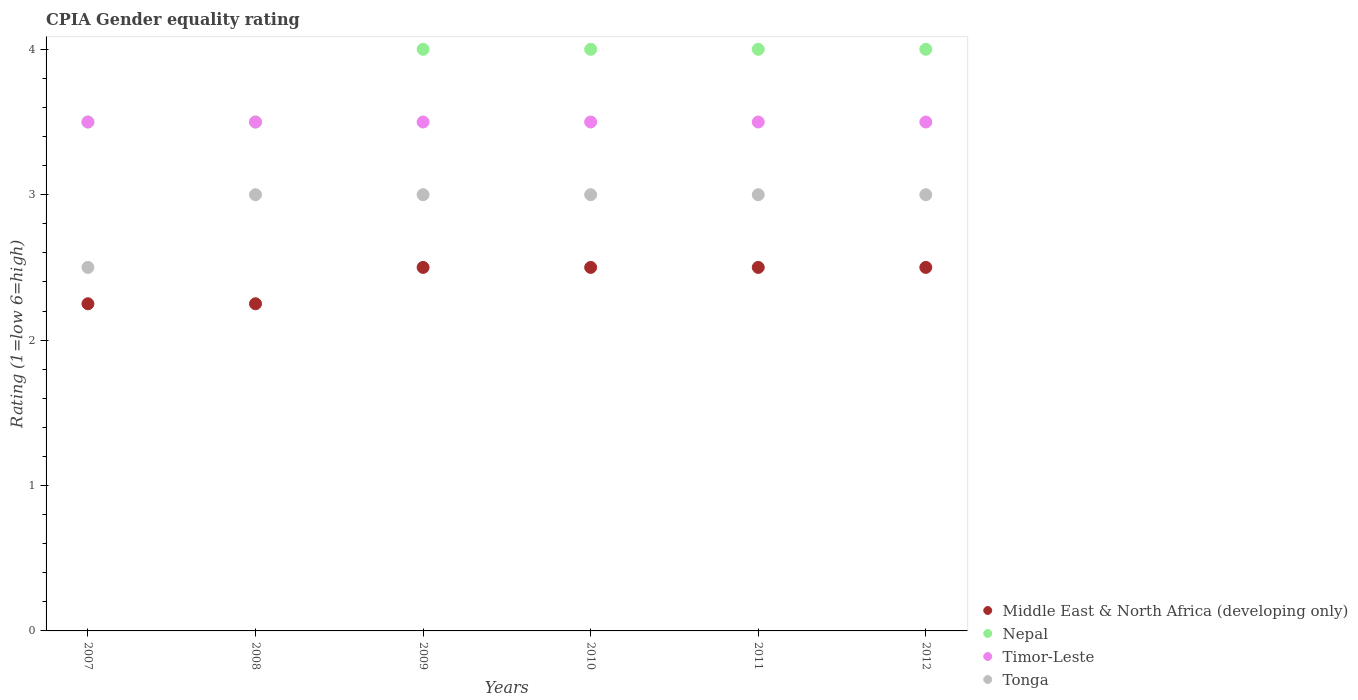How many different coloured dotlines are there?
Provide a succinct answer. 4. Across all years, what is the maximum CPIA rating in Tonga?
Give a very brief answer. 3. In which year was the CPIA rating in Timor-Leste maximum?
Ensure brevity in your answer.  2007. In which year was the CPIA rating in Tonga minimum?
Offer a terse response. 2007. What is the difference between the CPIA rating in Timor-Leste in 2009 and that in 2011?
Your response must be concise. 0. What is the difference between the CPIA rating in Tonga in 2012 and the CPIA rating in Timor-Leste in 2008?
Provide a succinct answer. -0.5. In the year 2011, what is the difference between the CPIA rating in Nepal and CPIA rating in Timor-Leste?
Provide a succinct answer. 0.5. In how many years, is the CPIA rating in Middle East & North Africa (developing only) greater than 1.6?
Offer a terse response. 6. Is the CPIA rating in Nepal in 2009 less than that in 2010?
Provide a succinct answer. No. Is the difference between the CPIA rating in Nepal in 2007 and 2008 greater than the difference between the CPIA rating in Timor-Leste in 2007 and 2008?
Ensure brevity in your answer.  No. What is the difference between the highest and the second highest CPIA rating in Middle East & North Africa (developing only)?
Ensure brevity in your answer.  0. In how many years, is the CPIA rating in Middle East & North Africa (developing only) greater than the average CPIA rating in Middle East & North Africa (developing only) taken over all years?
Your response must be concise. 4. Does the CPIA rating in Middle East & North Africa (developing only) monotonically increase over the years?
Keep it short and to the point. No. Is the CPIA rating in Tonga strictly less than the CPIA rating in Middle East & North Africa (developing only) over the years?
Keep it short and to the point. No. Does the graph contain any zero values?
Provide a short and direct response. No. Does the graph contain grids?
Offer a very short reply. No. Where does the legend appear in the graph?
Offer a very short reply. Bottom right. What is the title of the graph?
Your answer should be compact. CPIA Gender equality rating. What is the label or title of the X-axis?
Keep it short and to the point. Years. What is the label or title of the Y-axis?
Give a very brief answer. Rating (1=low 6=high). What is the Rating (1=low 6=high) of Middle East & North Africa (developing only) in 2007?
Your response must be concise. 2.25. What is the Rating (1=low 6=high) of Nepal in 2007?
Ensure brevity in your answer.  3.5. What is the Rating (1=low 6=high) of Tonga in 2007?
Ensure brevity in your answer.  2.5. What is the Rating (1=low 6=high) of Middle East & North Africa (developing only) in 2008?
Provide a succinct answer. 2.25. What is the Rating (1=low 6=high) of Tonga in 2008?
Ensure brevity in your answer.  3. What is the Rating (1=low 6=high) of Timor-Leste in 2009?
Provide a succinct answer. 3.5. What is the Rating (1=low 6=high) of Tonga in 2009?
Provide a succinct answer. 3. What is the Rating (1=low 6=high) of Nepal in 2010?
Give a very brief answer. 4. What is the Rating (1=low 6=high) of Timor-Leste in 2010?
Your response must be concise. 3.5. What is the Rating (1=low 6=high) of Tonga in 2010?
Make the answer very short. 3. What is the Rating (1=low 6=high) of Middle East & North Africa (developing only) in 2011?
Give a very brief answer. 2.5. What is the Rating (1=low 6=high) of Nepal in 2011?
Give a very brief answer. 4. What is the Rating (1=low 6=high) in Middle East & North Africa (developing only) in 2012?
Your answer should be very brief. 2.5. What is the Rating (1=low 6=high) of Timor-Leste in 2012?
Keep it short and to the point. 3.5. What is the Rating (1=low 6=high) in Tonga in 2012?
Give a very brief answer. 3. Across all years, what is the maximum Rating (1=low 6=high) of Tonga?
Provide a succinct answer. 3. Across all years, what is the minimum Rating (1=low 6=high) in Middle East & North Africa (developing only)?
Your answer should be very brief. 2.25. Across all years, what is the minimum Rating (1=low 6=high) of Nepal?
Your response must be concise. 3.5. What is the difference between the Rating (1=low 6=high) in Timor-Leste in 2007 and that in 2008?
Your answer should be very brief. 0. What is the difference between the Rating (1=low 6=high) in Nepal in 2007 and that in 2009?
Provide a short and direct response. -0.5. What is the difference between the Rating (1=low 6=high) of Nepal in 2007 and that in 2011?
Give a very brief answer. -0.5. What is the difference between the Rating (1=low 6=high) in Timor-Leste in 2007 and that in 2011?
Give a very brief answer. 0. What is the difference between the Rating (1=low 6=high) in Timor-Leste in 2007 and that in 2012?
Offer a very short reply. 0. What is the difference between the Rating (1=low 6=high) in Tonga in 2007 and that in 2012?
Ensure brevity in your answer.  -0.5. What is the difference between the Rating (1=low 6=high) in Nepal in 2008 and that in 2009?
Your answer should be compact. -0.5. What is the difference between the Rating (1=low 6=high) in Tonga in 2008 and that in 2009?
Provide a short and direct response. 0. What is the difference between the Rating (1=low 6=high) in Middle East & North Africa (developing only) in 2008 and that in 2010?
Your response must be concise. -0.25. What is the difference between the Rating (1=low 6=high) in Nepal in 2008 and that in 2010?
Make the answer very short. -0.5. What is the difference between the Rating (1=low 6=high) of Timor-Leste in 2008 and that in 2010?
Provide a short and direct response. 0. What is the difference between the Rating (1=low 6=high) in Nepal in 2008 and that in 2011?
Offer a very short reply. -0.5. What is the difference between the Rating (1=low 6=high) in Tonga in 2008 and that in 2011?
Provide a short and direct response. 0. What is the difference between the Rating (1=low 6=high) of Middle East & North Africa (developing only) in 2008 and that in 2012?
Provide a succinct answer. -0.25. What is the difference between the Rating (1=low 6=high) in Timor-Leste in 2008 and that in 2012?
Offer a very short reply. 0. What is the difference between the Rating (1=low 6=high) of Tonga in 2008 and that in 2012?
Your answer should be compact. 0. What is the difference between the Rating (1=low 6=high) of Middle East & North Africa (developing only) in 2009 and that in 2011?
Your response must be concise. 0. What is the difference between the Rating (1=low 6=high) of Nepal in 2009 and that in 2011?
Offer a terse response. 0. What is the difference between the Rating (1=low 6=high) of Tonga in 2009 and that in 2011?
Give a very brief answer. 0. What is the difference between the Rating (1=low 6=high) in Nepal in 2009 and that in 2012?
Ensure brevity in your answer.  0. What is the difference between the Rating (1=low 6=high) in Tonga in 2009 and that in 2012?
Offer a very short reply. 0. What is the difference between the Rating (1=low 6=high) of Middle East & North Africa (developing only) in 2010 and that in 2011?
Offer a very short reply. 0. What is the difference between the Rating (1=low 6=high) of Nepal in 2010 and that in 2011?
Make the answer very short. 0. What is the difference between the Rating (1=low 6=high) in Tonga in 2010 and that in 2011?
Provide a short and direct response. 0. What is the difference between the Rating (1=low 6=high) of Nepal in 2010 and that in 2012?
Your response must be concise. 0. What is the difference between the Rating (1=low 6=high) in Timor-Leste in 2010 and that in 2012?
Provide a succinct answer. 0. What is the difference between the Rating (1=low 6=high) of Middle East & North Africa (developing only) in 2011 and that in 2012?
Offer a very short reply. 0. What is the difference between the Rating (1=low 6=high) of Nepal in 2011 and that in 2012?
Provide a short and direct response. 0. What is the difference between the Rating (1=low 6=high) of Middle East & North Africa (developing only) in 2007 and the Rating (1=low 6=high) of Nepal in 2008?
Give a very brief answer. -1.25. What is the difference between the Rating (1=low 6=high) of Middle East & North Africa (developing only) in 2007 and the Rating (1=low 6=high) of Timor-Leste in 2008?
Provide a short and direct response. -1.25. What is the difference between the Rating (1=low 6=high) in Middle East & North Africa (developing only) in 2007 and the Rating (1=low 6=high) in Tonga in 2008?
Offer a terse response. -0.75. What is the difference between the Rating (1=low 6=high) of Nepal in 2007 and the Rating (1=low 6=high) of Tonga in 2008?
Give a very brief answer. 0.5. What is the difference between the Rating (1=low 6=high) of Middle East & North Africa (developing only) in 2007 and the Rating (1=low 6=high) of Nepal in 2009?
Provide a succinct answer. -1.75. What is the difference between the Rating (1=low 6=high) of Middle East & North Africa (developing only) in 2007 and the Rating (1=low 6=high) of Timor-Leste in 2009?
Ensure brevity in your answer.  -1.25. What is the difference between the Rating (1=low 6=high) of Middle East & North Africa (developing only) in 2007 and the Rating (1=low 6=high) of Tonga in 2009?
Make the answer very short. -0.75. What is the difference between the Rating (1=low 6=high) in Nepal in 2007 and the Rating (1=low 6=high) in Timor-Leste in 2009?
Keep it short and to the point. 0. What is the difference between the Rating (1=low 6=high) in Middle East & North Africa (developing only) in 2007 and the Rating (1=low 6=high) in Nepal in 2010?
Your answer should be very brief. -1.75. What is the difference between the Rating (1=low 6=high) of Middle East & North Africa (developing only) in 2007 and the Rating (1=low 6=high) of Timor-Leste in 2010?
Your answer should be compact. -1.25. What is the difference between the Rating (1=low 6=high) of Middle East & North Africa (developing only) in 2007 and the Rating (1=low 6=high) of Tonga in 2010?
Make the answer very short. -0.75. What is the difference between the Rating (1=low 6=high) in Nepal in 2007 and the Rating (1=low 6=high) in Timor-Leste in 2010?
Provide a succinct answer. 0. What is the difference between the Rating (1=low 6=high) of Middle East & North Africa (developing only) in 2007 and the Rating (1=low 6=high) of Nepal in 2011?
Offer a very short reply. -1.75. What is the difference between the Rating (1=low 6=high) of Middle East & North Africa (developing only) in 2007 and the Rating (1=low 6=high) of Timor-Leste in 2011?
Your answer should be very brief. -1.25. What is the difference between the Rating (1=low 6=high) of Middle East & North Africa (developing only) in 2007 and the Rating (1=low 6=high) of Tonga in 2011?
Provide a succinct answer. -0.75. What is the difference between the Rating (1=low 6=high) of Nepal in 2007 and the Rating (1=low 6=high) of Timor-Leste in 2011?
Ensure brevity in your answer.  0. What is the difference between the Rating (1=low 6=high) in Nepal in 2007 and the Rating (1=low 6=high) in Tonga in 2011?
Offer a terse response. 0.5. What is the difference between the Rating (1=low 6=high) of Timor-Leste in 2007 and the Rating (1=low 6=high) of Tonga in 2011?
Provide a succinct answer. 0.5. What is the difference between the Rating (1=low 6=high) of Middle East & North Africa (developing only) in 2007 and the Rating (1=low 6=high) of Nepal in 2012?
Make the answer very short. -1.75. What is the difference between the Rating (1=low 6=high) of Middle East & North Africa (developing only) in 2007 and the Rating (1=low 6=high) of Timor-Leste in 2012?
Keep it short and to the point. -1.25. What is the difference between the Rating (1=low 6=high) in Middle East & North Africa (developing only) in 2007 and the Rating (1=low 6=high) in Tonga in 2012?
Ensure brevity in your answer.  -0.75. What is the difference between the Rating (1=low 6=high) in Nepal in 2007 and the Rating (1=low 6=high) in Tonga in 2012?
Your answer should be very brief. 0.5. What is the difference between the Rating (1=low 6=high) in Timor-Leste in 2007 and the Rating (1=low 6=high) in Tonga in 2012?
Offer a terse response. 0.5. What is the difference between the Rating (1=low 6=high) in Middle East & North Africa (developing only) in 2008 and the Rating (1=low 6=high) in Nepal in 2009?
Give a very brief answer. -1.75. What is the difference between the Rating (1=low 6=high) of Middle East & North Africa (developing only) in 2008 and the Rating (1=low 6=high) of Timor-Leste in 2009?
Keep it short and to the point. -1.25. What is the difference between the Rating (1=low 6=high) in Middle East & North Africa (developing only) in 2008 and the Rating (1=low 6=high) in Tonga in 2009?
Provide a succinct answer. -0.75. What is the difference between the Rating (1=low 6=high) in Nepal in 2008 and the Rating (1=low 6=high) in Timor-Leste in 2009?
Ensure brevity in your answer.  0. What is the difference between the Rating (1=low 6=high) of Nepal in 2008 and the Rating (1=low 6=high) of Tonga in 2009?
Give a very brief answer. 0.5. What is the difference between the Rating (1=low 6=high) in Middle East & North Africa (developing only) in 2008 and the Rating (1=low 6=high) in Nepal in 2010?
Ensure brevity in your answer.  -1.75. What is the difference between the Rating (1=low 6=high) in Middle East & North Africa (developing only) in 2008 and the Rating (1=low 6=high) in Timor-Leste in 2010?
Make the answer very short. -1.25. What is the difference between the Rating (1=low 6=high) of Middle East & North Africa (developing only) in 2008 and the Rating (1=low 6=high) of Tonga in 2010?
Make the answer very short. -0.75. What is the difference between the Rating (1=low 6=high) in Nepal in 2008 and the Rating (1=low 6=high) in Timor-Leste in 2010?
Offer a terse response. 0. What is the difference between the Rating (1=low 6=high) in Timor-Leste in 2008 and the Rating (1=low 6=high) in Tonga in 2010?
Make the answer very short. 0.5. What is the difference between the Rating (1=low 6=high) in Middle East & North Africa (developing only) in 2008 and the Rating (1=low 6=high) in Nepal in 2011?
Make the answer very short. -1.75. What is the difference between the Rating (1=low 6=high) in Middle East & North Africa (developing only) in 2008 and the Rating (1=low 6=high) in Timor-Leste in 2011?
Give a very brief answer. -1.25. What is the difference between the Rating (1=low 6=high) of Middle East & North Africa (developing only) in 2008 and the Rating (1=low 6=high) of Tonga in 2011?
Offer a very short reply. -0.75. What is the difference between the Rating (1=low 6=high) in Nepal in 2008 and the Rating (1=low 6=high) in Timor-Leste in 2011?
Your answer should be very brief. 0. What is the difference between the Rating (1=low 6=high) of Nepal in 2008 and the Rating (1=low 6=high) of Tonga in 2011?
Offer a very short reply. 0.5. What is the difference between the Rating (1=low 6=high) of Timor-Leste in 2008 and the Rating (1=low 6=high) of Tonga in 2011?
Keep it short and to the point. 0.5. What is the difference between the Rating (1=low 6=high) in Middle East & North Africa (developing only) in 2008 and the Rating (1=low 6=high) in Nepal in 2012?
Keep it short and to the point. -1.75. What is the difference between the Rating (1=low 6=high) of Middle East & North Africa (developing only) in 2008 and the Rating (1=low 6=high) of Timor-Leste in 2012?
Offer a very short reply. -1.25. What is the difference between the Rating (1=low 6=high) in Middle East & North Africa (developing only) in 2008 and the Rating (1=low 6=high) in Tonga in 2012?
Offer a very short reply. -0.75. What is the difference between the Rating (1=low 6=high) in Nepal in 2008 and the Rating (1=low 6=high) in Tonga in 2012?
Your answer should be compact. 0.5. What is the difference between the Rating (1=low 6=high) of Timor-Leste in 2008 and the Rating (1=low 6=high) of Tonga in 2012?
Provide a short and direct response. 0.5. What is the difference between the Rating (1=low 6=high) in Middle East & North Africa (developing only) in 2009 and the Rating (1=low 6=high) in Nepal in 2010?
Your response must be concise. -1.5. What is the difference between the Rating (1=low 6=high) of Middle East & North Africa (developing only) in 2009 and the Rating (1=low 6=high) of Timor-Leste in 2010?
Your answer should be very brief. -1. What is the difference between the Rating (1=low 6=high) of Middle East & North Africa (developing only) in 2009 and the Rating (1=low 6=high) of Tonga in 2010?
Provide a succinct answer. -0.5. What is the difference between the Rating (1=low 6=high) of Nepal in 2009 and the Rating (1=low 6=high) of Tonga in 2010?
Make the answer very short. 1. What is the difference between the Rating (1=low 6=high) in Timor-Leste in 2009 and the Rating (1=low 6=high) in Tonga in 2010?
Provide a succinct answer. 0.5. What is the difference between the Rating (1=low 6=high) of Middle East & North Africa (developing only) in 2009 and the Rating (1=low 6=high) of Timor-Leste in 2011?
Your answer should be very brief. -1. What is the difference between the Rating (1=low 6=high) of Middle East & North Africa (developing only) in 2009 and the Rating (1=low 6=high) of Tonga in 2011?
Offer a terse response. -0.5. What is the difference between the Rating (1=low 6=high) of Nepal in 2009 and the Rating (1=low 6=high) of Timor-Leste in 2011?
Provide a succinct answer. 0.5. What is the difference between the Rating (1=low 6=high) in Nepal in 2009 and the Rating (1=low 6=high) in Tonga in 2011?
Your answer should be very brief. 1. What is the difference between the Rating (1=low 6=high) of Timor-Leste in 2009 and the Rating (1=low 6=high) of Tonga in 2011?
Keep it short and to the point. 0.5. What is the difference between the Rating (1=low 6=high) in Middle East & North Africa (developing only) in 2009 and the Rating (1=low 6=high) in Nepal in 2012?
Offer a terse response. -1.5. What is the difference between the Rating (1=low 6=high) of Middle East & North Africa (developing only) in 2009 and the Rating (1=low 6=high) of Tonga in 2012?
Make the answer very short. -0.5. What is the difference between the Rating (1=low 6=high) in Nepal in 2009 and the Rating (1=low 6=high) in Timor-Leste in 2012?
Your answer should be compact. 0.5. What is the difference between the Rating (1=low 6=high) in Timor-Leste in 2009 and the Rating (1=low 6=high) in Tonga in 2012?
Ensure brevity in your answer.  0.5. What is the difference between the Rating (1=low 6=high) of Nepal in 2010 and the Rating (1=low 6=high) of Tonga in 2011?
Provide a short and direct response. 1. What is the difference between the Rating (1=low 6=high) in Timor-Leste in 2010 and the Rating (1=low 6=high) in Tonga in 2011?
Your answer should be compact. 0.5. What is the difference between the Rating (1=low 6=high) of Middle East & North Africa (developing only) in 2010 and the Rating (1=low 6=high) of Timor-Leste in 2012?
Your answer should be compact. -1. What is the difference between the Rating (1=low 6=high) of Middle East & North Africa (developing only) in 2010 and the Rating (1=low 6=high) of Tonga in 2012?
Offer a terse response. -0.5. What is the difference between the Rating (1=low 6=high) in Nepal in 2010 and the Rating (1=low 6=high) in Tonga in 2012?
Ensure brevity in your answer.  1. What is the difference between the Rating (1=low 6=high) in Timor-Leste in 2010 and the Rating (1=low 6=high) in Tonga in 2012?
Offer a very short reply. 0.5. What is the difference between the Rating (1=low 6=high) of Middle East & North Africa (developing only) in 2011 and the Rating (1=low 6=high) of Tonga in 2012?
Give a very brief answer. -0.5. What is the difference between the Rating (1=low 6=high) of Timor-Leste in 2011 and the Rating (1=low 6=high) of Tonga in 2012?
Keep it short and to the point. 0.5. What is the average Rating (1=low 6=high) in Middle East & North Africa (developing only) per year?
Give a very brief answer. 2.42. What is the average Rating (1=low 6=high) of Nepal per year?
Provide a short and direct response. 3.83. What is the average Rating (1=low 6=high) of Timor-Leste per year?
Ensure brevity in your answer.  3.5. What is the average Rating (1=low 6=high) in Tonga per year?
Keep it short and to the point. 2.92. In the year 2007, what is the difference between the Rating (1=low 6=high) in Middle East & North Africa (developing only) and Rating (1=low 6=high) in Nepal?
Give a very brief answer. -1.25. In the year 2007, what is the difference between the Rating (1=low 6=high) in Middle East & North Africa (developing only) and Rating (1=low 6=high) in Timor-Leste?
Your answer should be very brief. -1.25. In the year 2007, what is the difference between the Rating (1=low 6=high) of Middle East & North Africa (developing only) and Rating (1=low 6=high) of Tonga?
Keep it short and to the point. -0.25. In the year 2007, what is the difference between the Rating (1=low 6=high) in Nepal and Rating (1=low 6=high) in Timor-Leste?
Keep it short and to the point. 0. In the year 2007, what is the difference between the Rating (1=low 6=high) in Nepal and Rating (1=low 6=high) in Tonga?
Provide a short and direct response. 1. In the year 2007, what is the difference between the Rating (1=low 6=high) of Timor-Leste and Rating (1=low 6=high) of Tonga?
Your response must be concise. 1. In the year 2008, what is the difference between the Rating (1=low 6=high) of Middle East & North Africa (developing only) and Rating (1=low 6=high) of Nepal?
Give a very brief answer. -1.25. In the year 2008, what is the difference between the Rating (1=low 6=high) in Middle East & North Africa (developing only) and Rating (1=low 6=high) in Timor-Leste?
Offer a terse response. -1.25. In the year 2008, what is the difference between the Rating (1=low 6=high) of Middle East & North Africa (developing only) and Rating (1=low 6=high) of Tonga?
Provide a short and direct response. -0.75. In the year 2008, what is the difference between the Rating (1=low 6=high) in Timor-Leste and Rating (1=low 6=high) in Tonga?
Ensure brevity in your answer.  0.5. In the year 2009, what is the difference between the Rating (1=low 6=high) of Middle East & North Africa (developing only) and Rating (1=low 6=high) of Nepal?
Offer a very short reply. -1.5. In the year 2009, what is the difference between the Rating (1=low 6=high) in Middle East & North Africa (developing only) and Rating (1=low 6=high) in Timor-Leste?
Ensure brevity in your answer.  -1. In the year 2009, what is the difference between the Rating (1=low 6=high) in Middle East & North Africa (developing only) and Rating (1=low 6=high) in Tonga?
Your answer should be compact. -0.5. In the year 2009, what is the difference between the Rating (1=low 6=high) in Nepal and Rating (1=low 6=high) in Tonga?
Ensure brevity in your answer.  1. In the year 2009, what is the difference between the Rating (1=low 6=high) of Timor-Leste and Rating (1=low 6=high) of Tonga?
Provide a succinct answer. 0.5. In the year 2010, what is the difference between the Rating (1=low 6=high) of Middle East & North Africa (developing only) and Rating (1=low 6=high) of Nepal?
Ensure brevity in your answer.  -1.5. In the year 2010, what is the difference between the Rating (1=low 6=high) of Nepal and Rating (1=low 6=high) of Tonga?
Offer a terse response. 1. In the year 2011, what is the difference between the Rating (1=low 6=high) of Middle East & North Africa (developing only) and Rating (1=low 6=high) of Timor-Leste?
Give a very brief answer. -1. In the year 2012, what is the difference between the Rating (1=low 6=high) in Middle East & North Africa (developing only) and Rating (1=low 6=high) in Nepal?
Provide a succinct answer. -1.5. In the year 2012, what is the difference between the Rating (1=low 6=high) in Middle East & North Africa (developing only) and Rating (1=low 6=high) in Timor-Leste?
Make the answer very short. -1. In the year 2012, what is the difference between the Rating (1=low 6=high) of Middle East & North Africa (developing only) and Rating (1=low 6=high) of Tonga?
Your response must be concise. -0.5. In the year 2012, what is the difference between the Rating (1=low 6=high) in Nepal and Rating (1=low 6=high) in Timor-Leste?
Your response must be concise. 0.5. What is the ratio of the Rating (1=low 6=high) of Nepal in 2007 to that in 2008?
Offer a terse response. 1. What is the ratio of the Rating (1=low 6=high) of Timor-Leste in 2007 to that in 2009?
Offer a very short reply. 1. What is the ratio of the Rating (1=low 6=high) of Tonga in 2007 to that in 2009?
Offer a terse response. 0.83. What is the ratio of the Rating (1=low 6=high) in Tonga in 2007 to that in 2010?
Offer a terse response. 0.83. What is the ratio of the Rating (1=low 6=high) in Middle East & North Africa (developing only) in 2007 to that in 2011?
Your answer should be very brief. 0.9. What is the ratio of the Rating (1=low 6=high) of Nepal in 2007 to that in 2011?
Your answer should be very brief. 0.88. What is the ratio of the Rating (1=low 6=high) in Timor-Leste in 2007 to that in 2011?
Give a very brief answer. 1. What is the ratio of the Rating (1=low 6=high) of Timor-Leste in 2007 to that in 2012?
Your response must be concise. 1. What is the ratio of the Rating (1=low 6=high) in Middle East & North Africa (developing only) in 2008 to that in 2009?
Your response must be concise. 0.9. What is the ratio of the Rating (1=low 6=high) in Timor-Leste in 2008 to that in 2009?
Make the answer very short. 1. What is the ratio of the Rating (1=low 6=high) of Tonga in 2008 to that in 2009?
Give a very brief answer. 1. What is the ratio of the Rating (1=low 6=high) of Middle East & North Africa (developing only) in 2008 to that in 2010?
Keep it short and to the point. 0.9. What is the ratio of the Rating (1=low 6=high) of Nepal in 2008 to that in 2010?
Offer a terse response. 0.88. What is the ratio of the Rating (1=low 6=high) of Timor-Leste in 2008 to that in 2010?
Your answer should be compact. 1. What is the ratio of the Rating (1=low 6=high) in Tonga in 2008 to that in 2010?
Your response must be concise. 1. What is the ratio of the Rating (1=low 6=high) of Middle East & North Africa (developing only) in 2008 to that in 2011?
Your answer should be very brief. 0.9. What is the ratio of the Rating (1=low 6=high) in Nepal in 2008 to that in 2011?
Give a very brief answer. 0.88. What is the ratio of the Rating (1=low 6=high) of Timor-Leste in 2008 to that in 2011?
Make the answer very short. 1. What is the ratio of the Rating (1=low 6=high) of Tonga in 2008 to that in 2012?
Keep it short and to the point. 1. What is the ratio of the Rating (1=low 6=high) of Middle East & North Africa (developing only) in 2009 to that in 2010?
Offer a terse response. 1. What is the ratio of the Rating (1=low 6=high) of Timor-Leste in 2009 to that in 2011?
Give a very brief answer. 1. What is the ratio of the Rating (1=low 6=high) in Tonga in 2009 to that in 2011?
Your answer should be very brief. 1. What is the ratio of the Rating (1=low 6=high) of Nepal in 2009 to that in 2012?
Offer a terse response. 1. What is the ratio of the Rating (1=low 6=high) of Middle East & North Africa (developing only) in 2010 to that in 2011?
Ensure brevity in your answer.  1. What is the ratio of the Rating (1=low 6=high) in Nepal in 2010 to that in 2011?
Make the answer very short. 1. What is the ratio of the Rating (1=low 6=high) in Tonga in 2010 to that in 2012?
Provide a succinct answer. 1. What is the ratio of the Rating (1=low 6=high) in Middle East & North Africa (developing only) in 2011 to that in 2012?
Provide a succinct answer. 1. What is the ratio of the Rating (1=low 6=high) of Nepal in 2011 to that in 2012?
Give a very brief answer. 1. What is the ratio of the Rating (1=low 6=high) of Tonga in 2011 to that in 2012?
Offer a terse response. 1. What is the difference between the highest and the second highest Rating (1=low 6=high) in Middle East & North Africa (developing only)?
Provide a short and direct response. 0. What is the difference between the highest and the second highest Rating (1=low 6=high) in Timor-Leste?
Ensure brevity in your answer.  0. What is the difference between the highest and the second highest Rating (1=low 6=high) of Tonga?
Make the answer very short. 0. What is the difference between the highest and the lowest Rating (1=low 6=high) of Timor-Leste?
Your answer should be very brief. 0. 